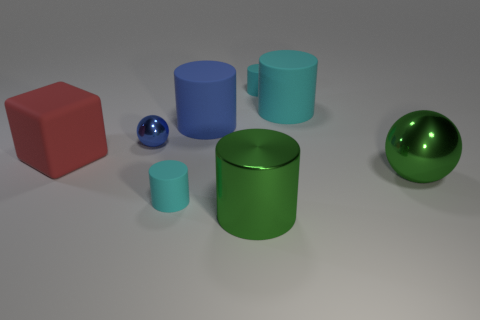The big object that is the same color as the metallic cylinder is what shape?
Your response must be concise. Sphere. What number of rubber objects are to the left of the green metal cylinder?
Your response must be concise. 3. Is the large red thing the same shape as the large cyan thing?
Offer a very short reply. No. What number of small objects are both behind the big metallic ball and in front of the big cyan matte cylinder?
Offer a very short reply. 1. What number of objects are either large blue things or rubber cylinders behind the big green metal sphere?
Offer a very short reply. 3. Is the number of large blue matte cubes greater than the number of big matte things?
Offer a very short reply. No. The blue thing that is in front of the big blue cylinder has what shape?
Ensure brevity in your answer.  Sphere. What number of large green shiny things have the same shape as the small blue metallic object?
Make the answer very short. 1. What size is the sphere that is left of the large green metallic ball that is in front of the large matte block?
Offer a very short reply. Small. How many cyan objects are matte spheres or small objects?
Provide a short and direct response. 2. 